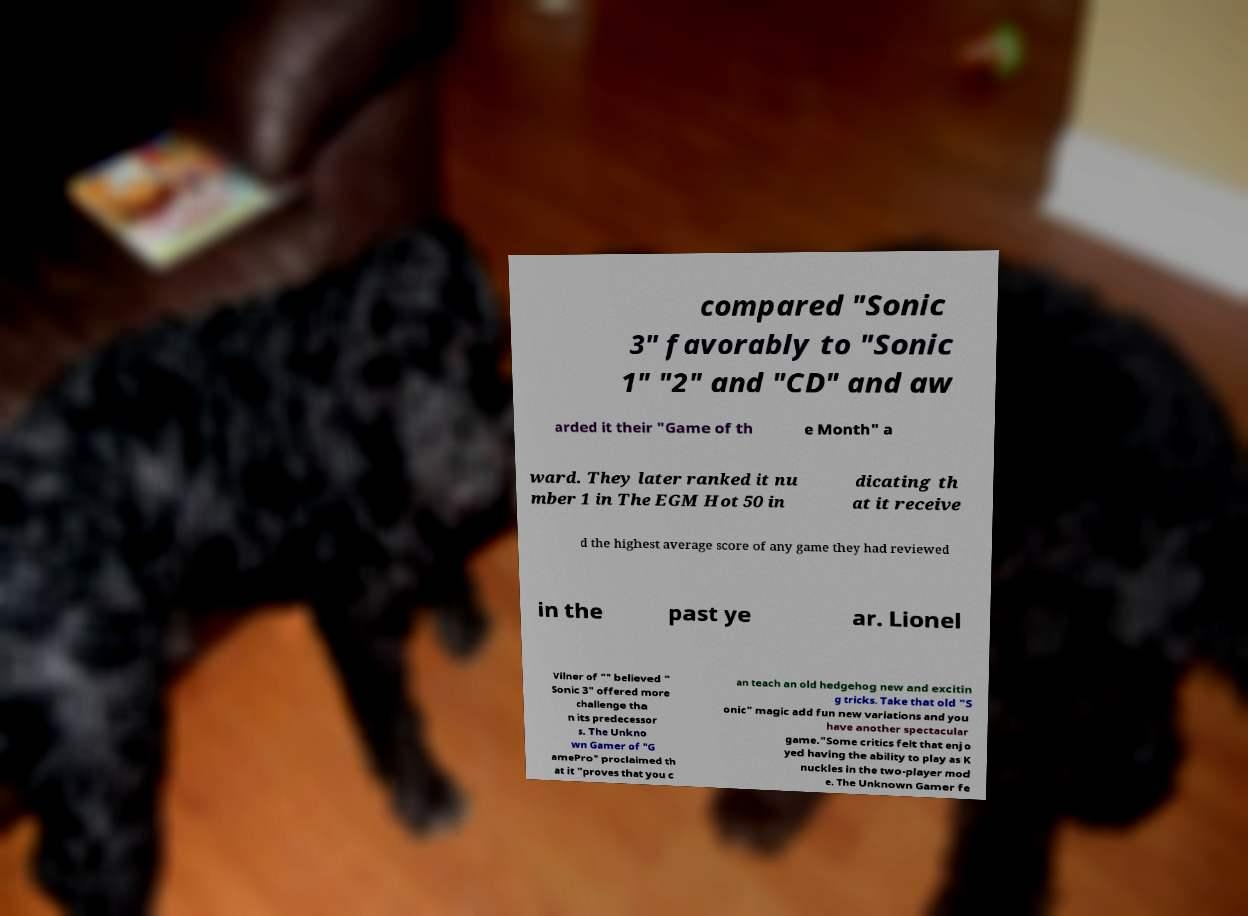I need the written content from this picture converted into text. Can you do that? compared "Sonic 3" favorably to "Sonic 1" "2" and "CD" and aw arded it their "Game of th e Month" a ward. They later ranked it nu mber 1 in The EGM Hot 50 in dicating th at it receive d the highest average score of any game they had reviewed in the past ye ar. Lionel Vilner of "" believed " Sonic 3" offered more challenge tha n its predecessor s. The Unkno wn Gamer of "G amePro" proclaimed th at it "proves that you c an teach an old hedgehog new and excitin g tricks. Take that old "S onic" magic add fun new variations and you have another spectacular game."Some critics felt that enjo yed having the ability to play as K nuckles in the two-player mod e. The Unknown Gamer fe 